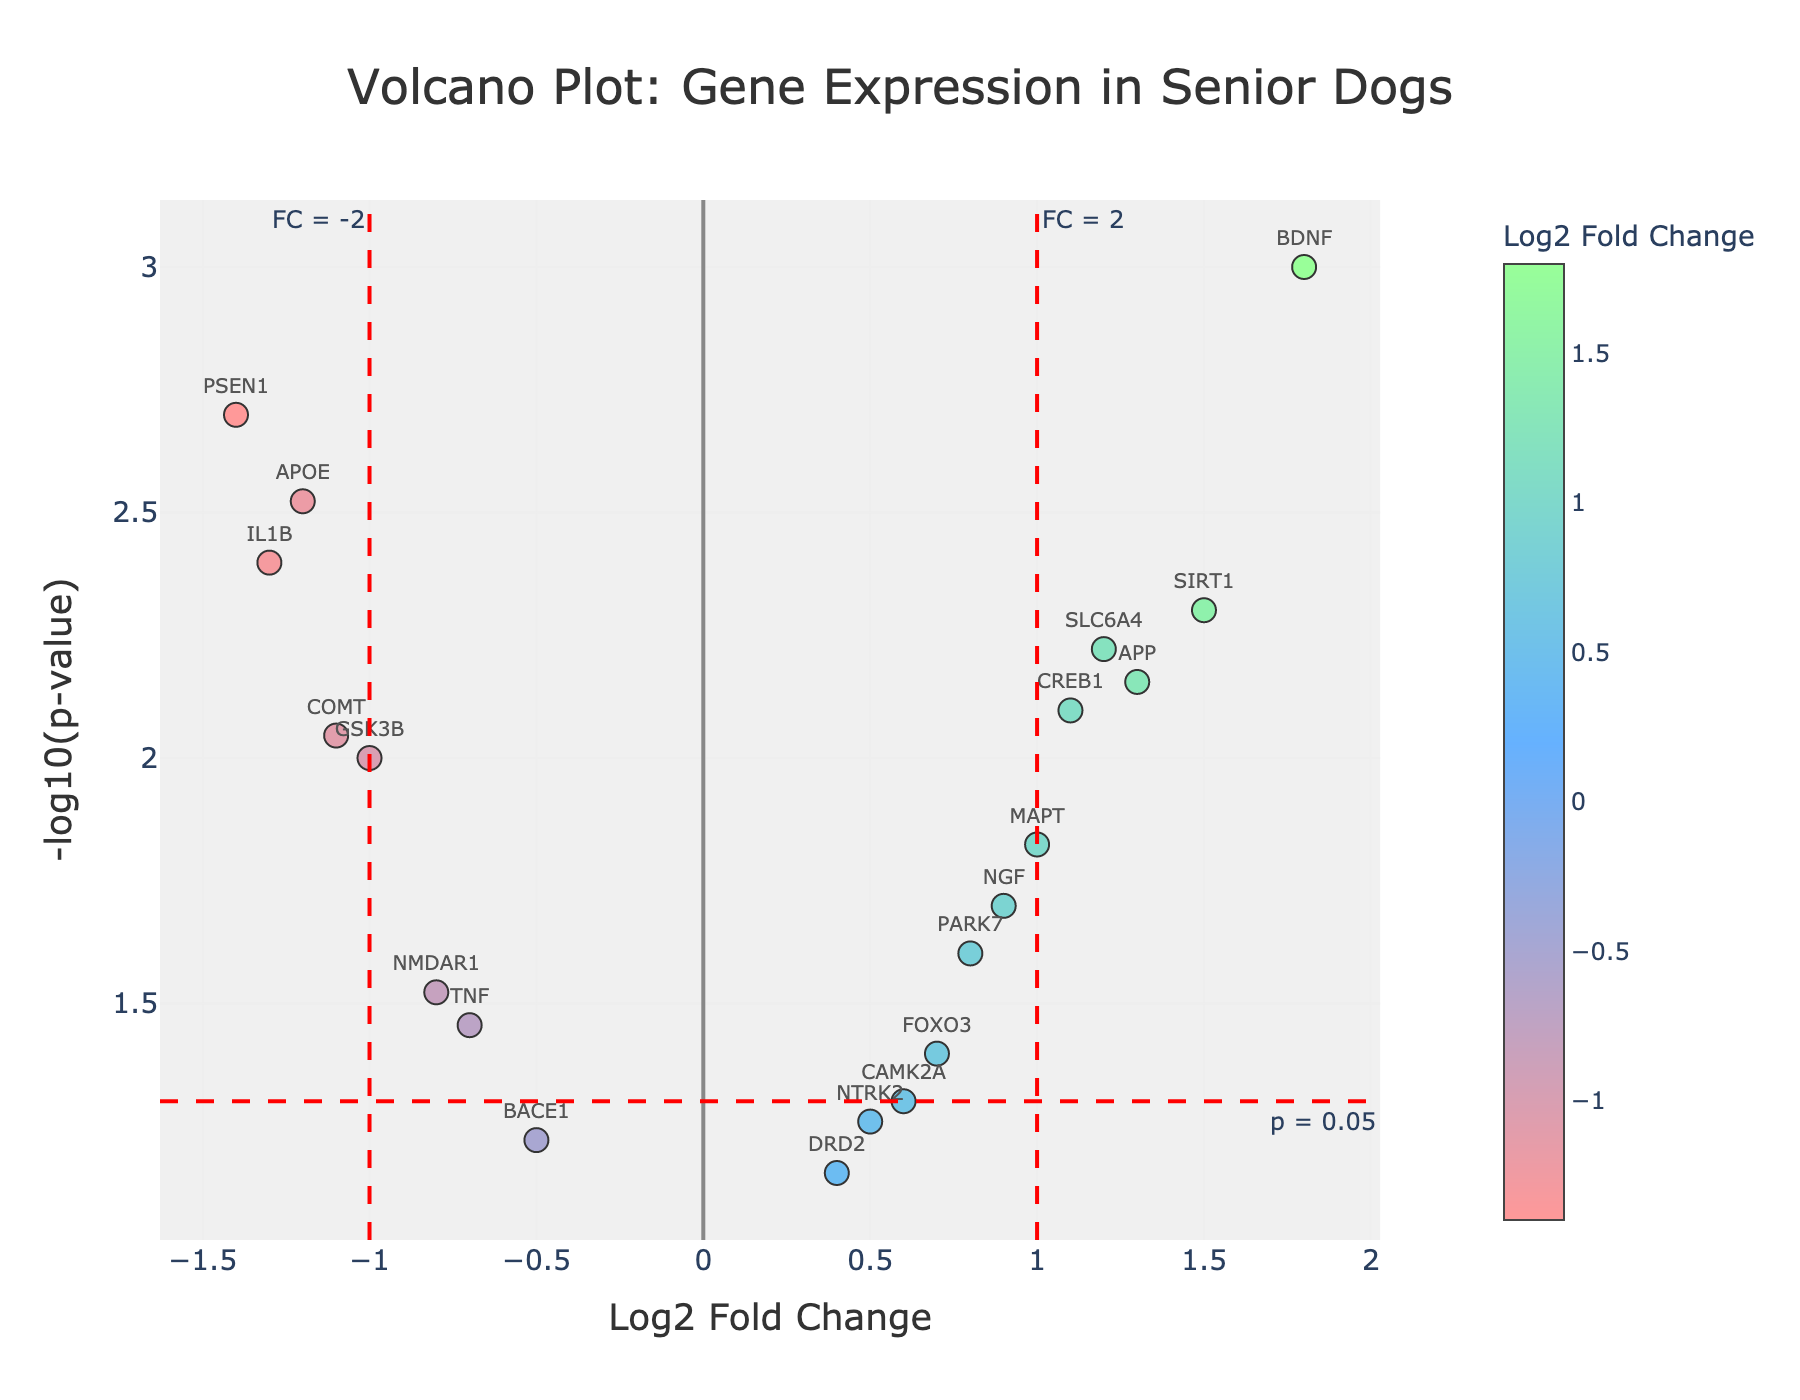How many genes are represented in the plot? Count the distinct data points on the plot, each representing a gene.
Answer: 20 What is the title of the plot? Read the text at the top of the figure where the title is located.
Answer: Volcano Plot: Gene Expression in Senior Dogs Which gene has the highest log2 fold change? Look for the gene associated with the highest log2 fold change on the x-axis.
Answer: BDNF Which gene has the lowest p-value? Identify the gene that positions highest on the y-axis, which correlates to the lowest p-value.
Answer: BDNF What is the log2 fold change and p-value of the gene SIRT1? Locate the point labeled SIRT1 and refer to its tooltip or position on the axes.
Answer: Log2 Fold Change: 1.5, p-value: 0.005 Are there any genes with a log2 fold change greater than 1 and a p-value less than 0.05? Identify the genes to the right of the x-axis threshold line (Log2 Fold Change > 1) and above the y-axis threshold line (-log10(p-value) > 1.301).
Answer: BDNF, APP, SLC6A4 Which genes fall into the significantly downregulated category given the thresholds used (log2 fold change < -1, p < 0.05)? Look for genes left of the x-axis threshold line (Log2 Fold Change < -1) and above the y-axis threshold line (-log10(p-value) > 1.301).
Answer: APOE, PSEN1, IL1B What is the range of -log10(p-value) among the genes? Find the minimum and maximum -log10(p-value) on the y-axis.
Answer: 0.585 to 3.000 Which genes have a log2 fold change between -0.5 and 0.5? Identify the genes located within the specified range on the x-axis.
Answer: DRD2, NTRK2, CAMK2A, TNF, BACE1 